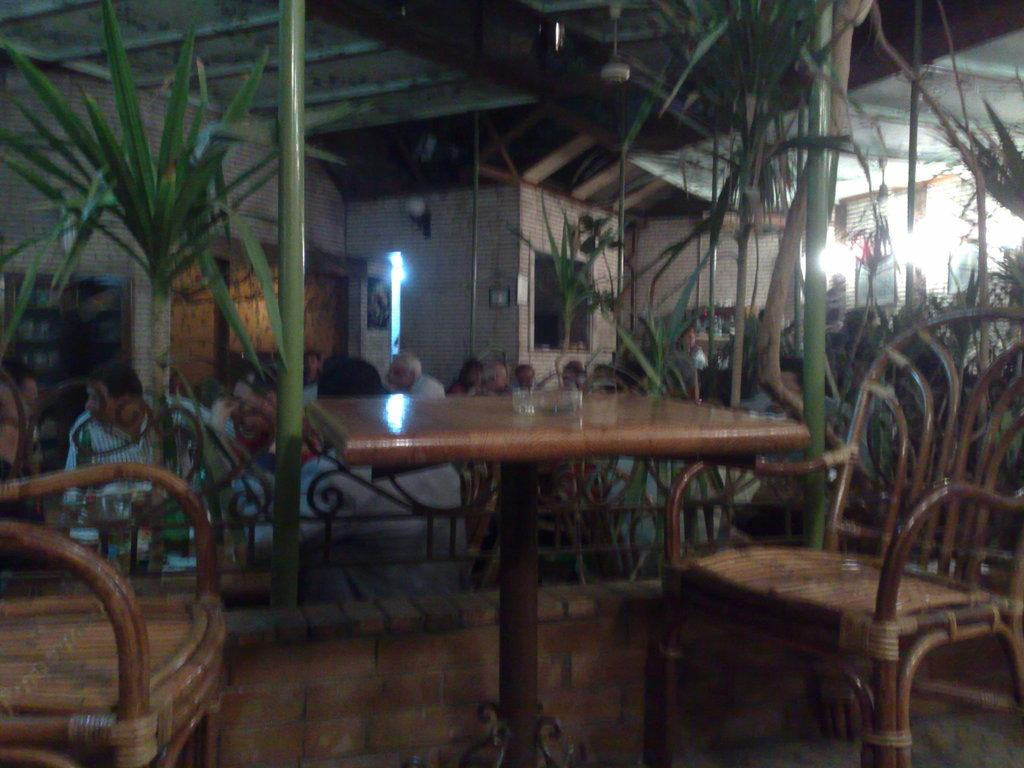What type of establishment is depicted in the image? The image shows a view of a restaurant. What furniture is present in the image? There is a wooden table and chairs in the image. What type of vegetation is visible in the image? There are plants in the image. What can be seen in the background of the image? There is a house and a shed roof visible in the background. What type of muscle is being exercised by the plants in the image? Plants do not have muscles, so this question is not applicable to the image. 